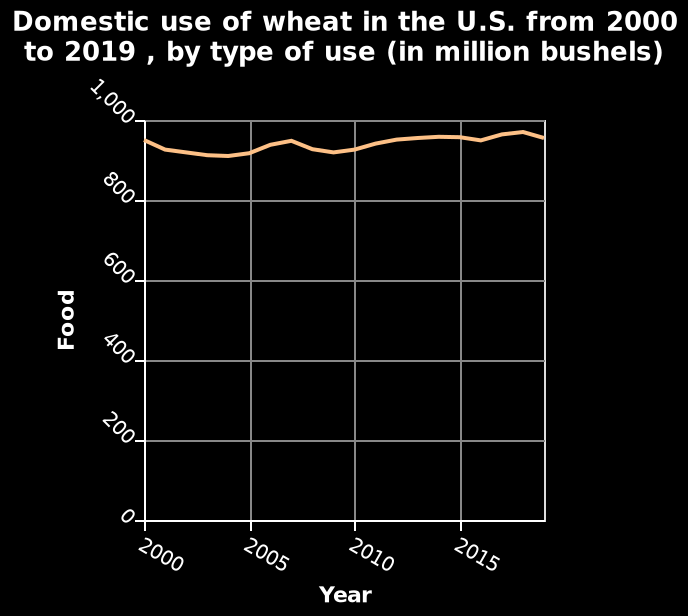<image>
please summary the statistics and relations of the chart the domestic use of wheat in the US from 2000 to 2019 has gradually increased a small amount, although it has sometimes dipped. What is the range of values for the domestic use of wheat in the line plot? The range of values for the domestic use of wheat is not specified in the description. What is being measured on the y-axis in the line plot?  The y-axis measures the domestic use of wheat in million bushels. Has the domestic use of wheat in the US from 2000 to 2019 dramatically increased a large amount, although it has never dipped? No.the domestic use of wheat in the US from 2000 to 2019 has gradually increased a small amount, although it has sometimes dipped. 